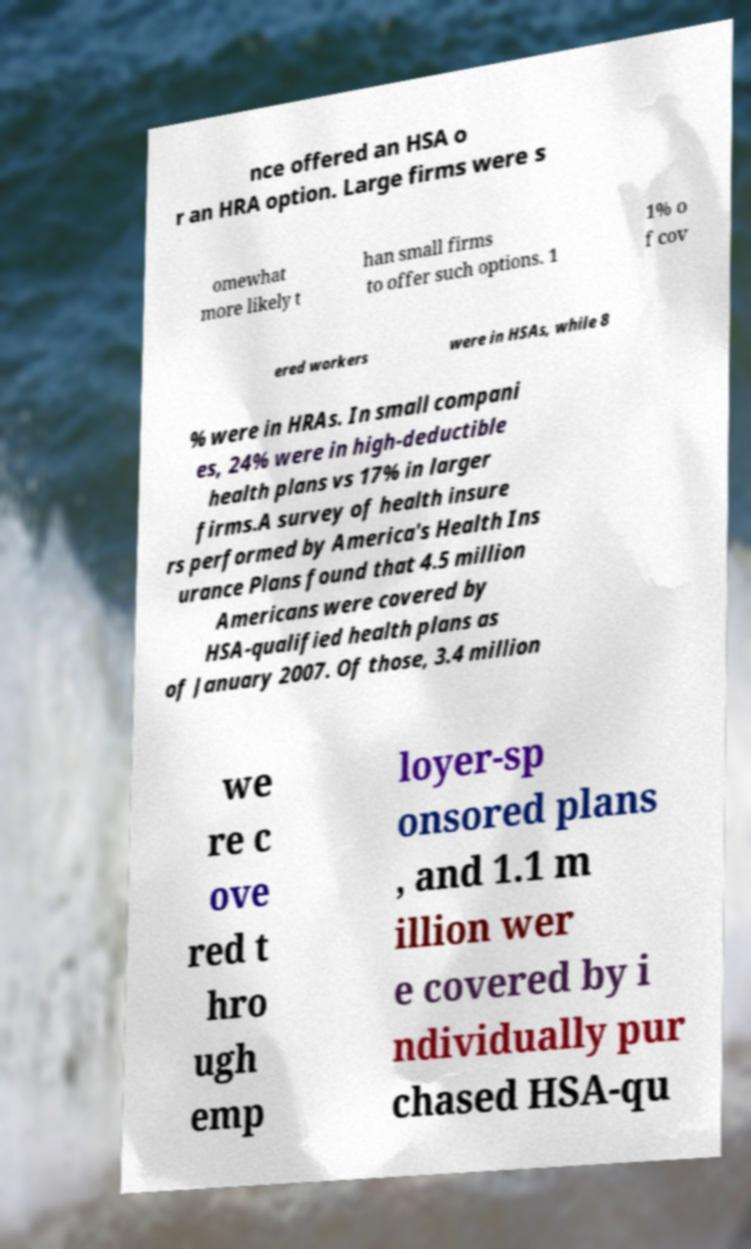Please read and relay the text visible in this image. What does it say? nce offered an HSA o r an HRA option. Large firms were s omewhat more likely t han small firms to offer such options. 1 1% o f cov ered workers were in HSAs, while 8 % were in HRAs. In small compani es, 24% were in high-deductible health plans vs 17% in larger firms.A survey of health insure rs performed by America's Health Ins urance Plans found that 4.5 million Americans were covered by HSA-qualified health plans as of January 2007. Of those, 3.4 million we re c ove red t hro ugh emp loyer-sp onsored plans , and 1.1 m illion wer e covered by i ndividually pur chased HSA-qu 